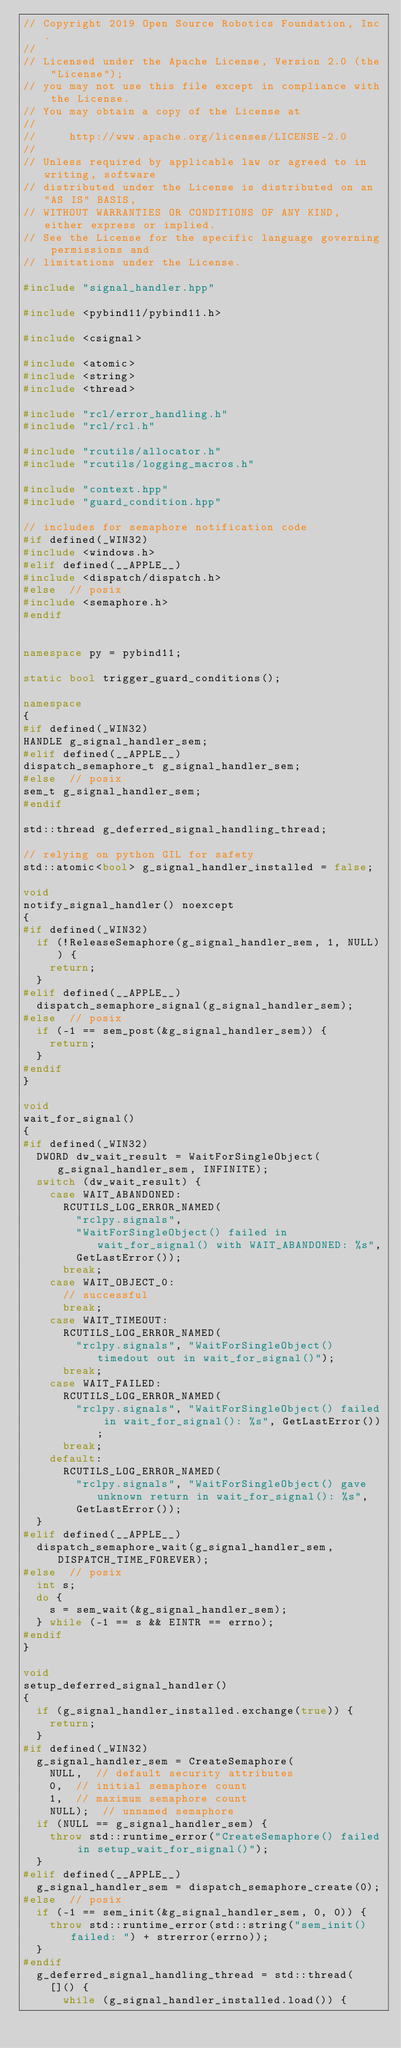<code> <loc_0><loc_0><loc_500><loc_500><_C++_>// Copyright 2019 Open Source Robotics Foundation, Inc.
//
// Licensed under the Apache License, Version 2.0 (the "License");
// you may not use this file except in compliance with the License.
// You may obtain a copy of the License at
//
//     http://www.apache.org/licenses/LICENSE-2.0
//
// Unless required by applicable law or agreed to in writing, software
// distributed under the License is distributed on an "AS IS" BASIS,
// WITHOUT WARRANTIES OR CONDITIONS OF ANY KIND, either express or implied.
// See the License for the specific language governing permissions and
// limitations under the License.

#include "signal_handler.hpp"

#include <pybind11/pybind11.h>

#include <csignal>

#include <atomic>
#include <string>
#include <thread>

#include "rcl/error_handling.h"
#include "rcl/rcl.h"

#include "rcutils/allocator.h"
#include "rcutils/logging_macros.h"

#include "context.hpp"
#include "guard_condition.hpp"

// includes for semaphore notification code
#if defined(_WIN32)
#include <windows.h>
#elif defined(__APPLE__)
#include <dispatch/dispatch.h>
#else  // posix
#include <semaphore.h>
#endif


namespace py = pybind11;

static bool trigger_guard_conditions();

namespace
{
#if defined(_WIN32)
HANDLE g_signal_handler_sem;
#elif defined(__APPLE__)
dispatch_semaphore_t g_signal_handler_sem;
#else  // posix
sem_t g_signal_handler_sem;
#endif

std::thread g_deferred_signal_handling_thread;

// relying on python GIL for safety
std::atomic<bool> g_signal_handler_installed = false;

void
notify_signal_handler() noexcept
{
#if defined(_WIN32)
  if (!ReleaseSemaphore(g_signal_handler_sem, 1, NULL)) {
    return;
  }
#elif defined(__APPLE__)
  dispatch_semaphore_signal(g_signal_handler_sem);
#else  // posix
  if (-1 == sem_post(&g_signal_handler_sem)) {
    return;
  }
#endif
}

void
wait_for_signal()
{
#if defined(_WIN32)
  DWORD dw_wait_result = WaitForSingleObject(g_signal_handler_sem, INFINITE);
  switch (dw_wait_result) {
    case WAIT_ABANDONED:
      RCUTILS_LOG_ERROR_NAMED(
        "rclpy.signals",
        "WaitForSingleObject() failed in wait_for_signal() with WAIT_ABANDONED: %s",
        GetLastError());
      break;
    case WAIT_OBJECT_0:
      // successful
      break;
    case WAIT_TIMEOUT:
      RCUTILS_LOG_ERROR_NAMED(
        "rclpy.signals", "WaitForSingleObject() timedout out in wait_for_signal()");
      break;
    case WAIT_FAILED:
      RCUTILS_LOG_ERROR_NAMED(
        "rclpy.signals", "WaitForSingleObject() failed in wait_for_signal(): %s", GetLastError());
      break;
    default:
      RCUTILS_LOG_ERROR_NAMED(
        "rclpy.signals", "WaitForSingleObject() gave unknown return in wait_for_signal(): %s",
        GetLastError());
  }
#elif defined(__APPLE__)
  dispatch_semaphore_wait(g_signal_handler_sem, DISPATCH_TIME_FOREVER);
#else  // posix
  int s;
  do {
    s = sem_wait(&g_signal_handler_sem);
  } while (-1 == s && EINTR == errno);
#endif
}

void
setup_deferred_signal_handler()
{
  if (g_signal_handler_installed.exchange(true)) {
    return;
  }
#if defined(_WIN32)
  g_signal_handler_sem = CreateSemaphore(
    NULL,  // default security attributes
    0,  // initial semaphore count
    1,  // maximum semaphore count
    NULL);  // unnamed semaphore
  if (NULL == g_signal_handler_sem) {
    throw std::runtime_error("CreateSemaphore() failed in setup_wait_for_signal()");
  }
#elif defined(__APPLE__)
  g_signal_handler_sem = dispatch_semaphore_create(0);
#else  // posix
  if (-1 == sem_init(&g_signal_handler_sem, 0, 0)) {
    throw std::runtime_error(std::string("sem_init() failed: ") + strerror(errno));
  }
#endif
  g_deferred_signal_handling_thread = std::thread(
    []() {
      while (g_signal_handler_installed.load()) {</code> 